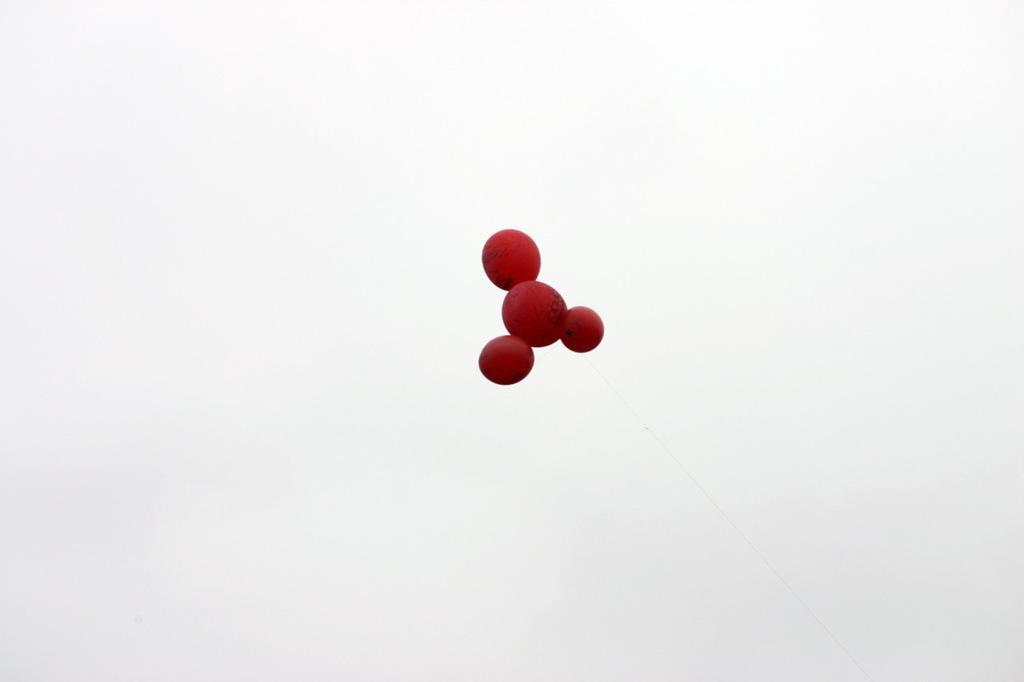In one or two sentences, can you explain what this image depicts? There is brown color animated molecule of an object. And the background is white in color. 